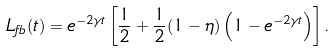<formula> <loc_0><loc_0><loc_500><loc_500>L _ { f b } ( t ) = e ^ { - 2 \gamma t } \left [ \frac { 1 } { 2 } + \frac { 1 } { 2 } ( 1 - \eta ) \left ( 1 - e ^ { - 2 \gamma t } \right ) \right ] .</formula> 